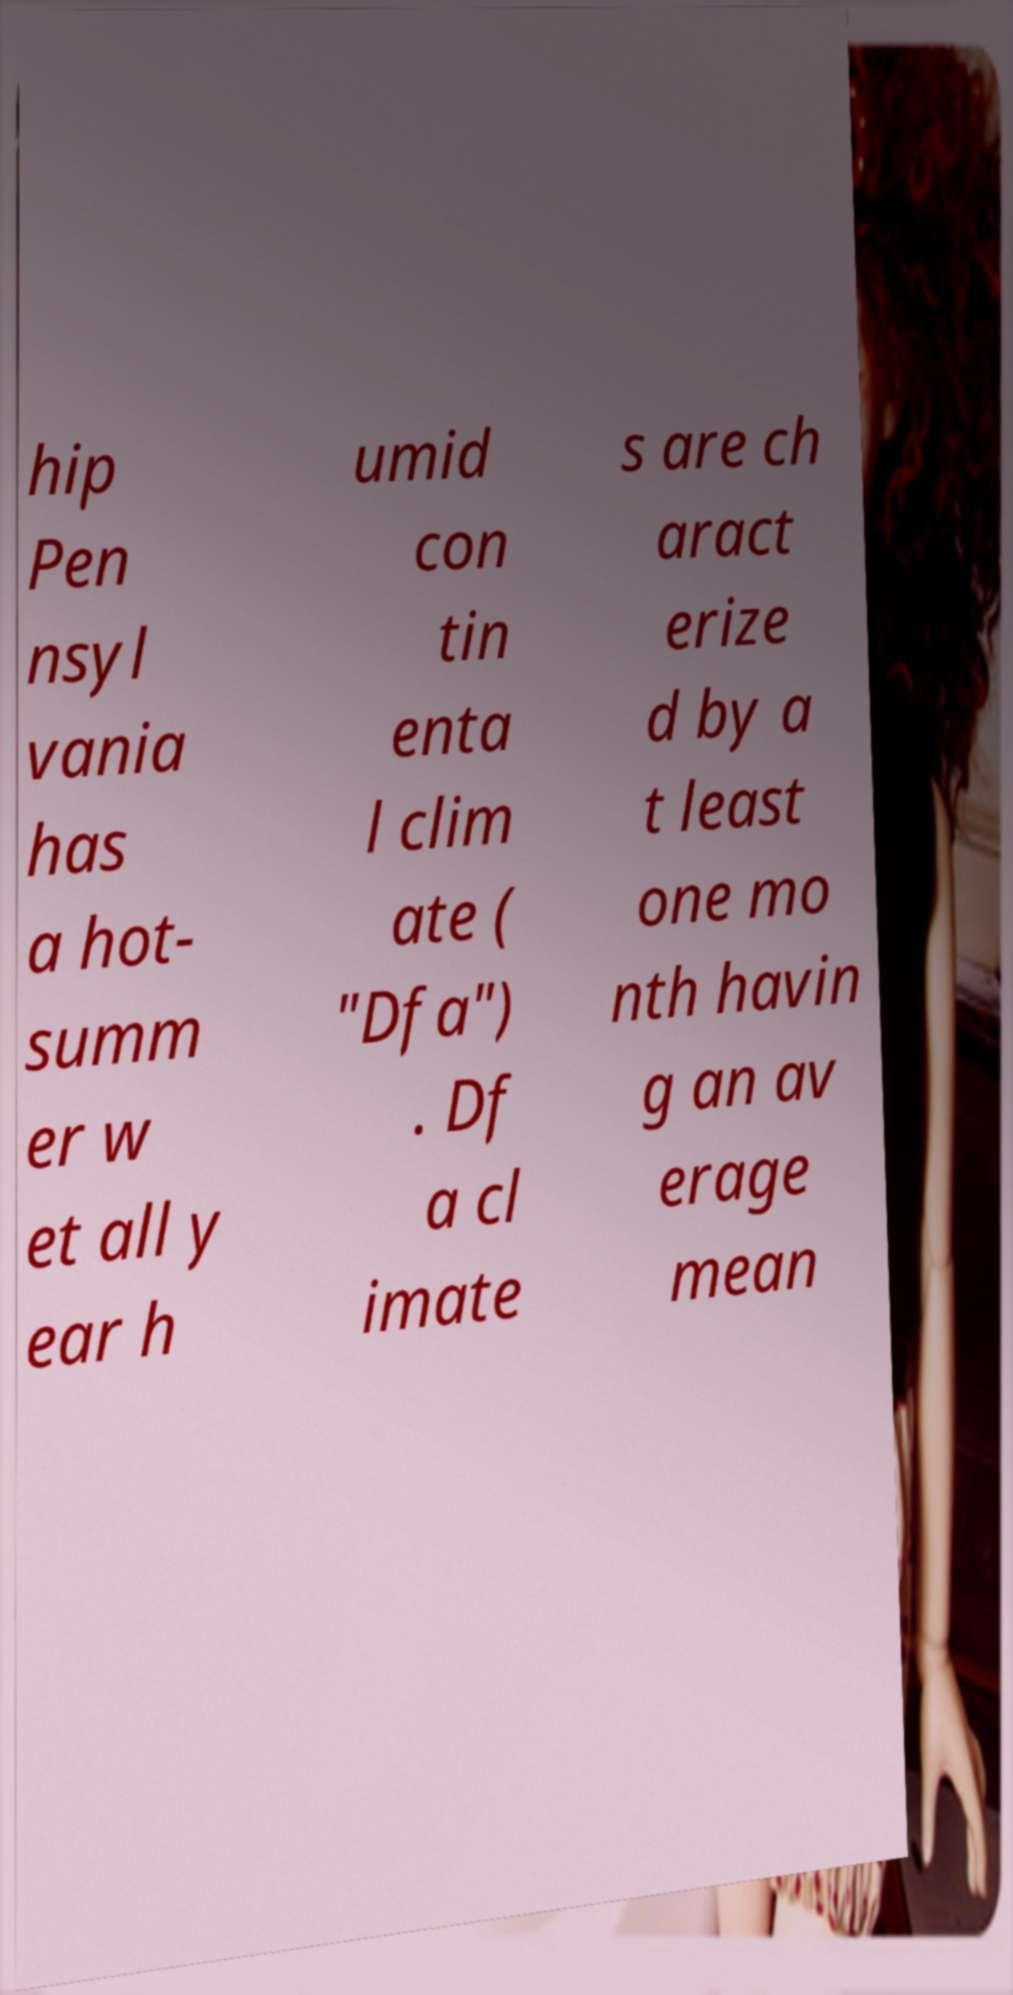There's text embedded in this image that I need extracted. Can you transcribe it verbatim? hip Pen nsyl vania has a hot- summ er w et all y ear h umid con tin enta l clim ate ( "Dfa") . Df a cl imate s are ch aract erize d by a t least one mo nth havin g an av erage mean 